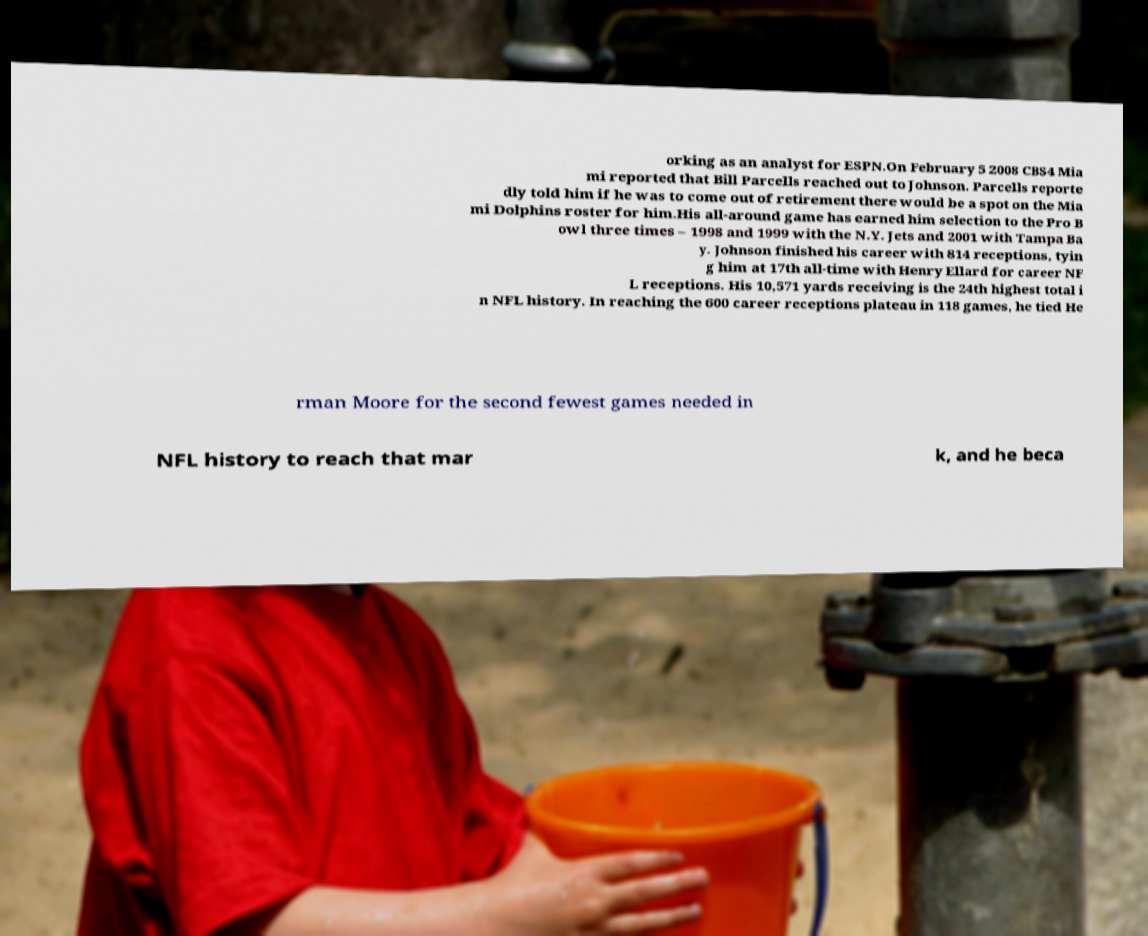Can you read and provide the text displayed in the image?This photo seems to have some interesting text. Can you extract and type it out for me? orking as an analyst for ESPN.On February 5 2008 CBS4 Mia mi reported that Bill Parcells reached out to Johnson. Parcells reporte dly told him if he was to come out of retirement there would be a spot on the Mia mi Dolphins roster for him.His all-around game has earned him selection to the Pro B owl three times – 1998 and 1999 with the N.Y. Jets and 2001 with Tampa Ba y. Johnson finished his career with 814 receptions, tyin g him at 17th all-time with Henry Ellard for career NF L receptions. His 10,571 yards receiving is the 24th highest total i n NFL history. In reaching the 600 career receptions plateau in 118 games, he tied He rman Moore for the second fewest games needed in NFL history to reach that mar k, and he beca 